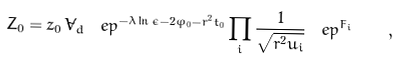Convert formula to latex. <formula><loc_0><loc_0><loc_500><loc_500>Z _ { 0 } = z _ { 0 } \, \tilde { V } _ { d } \, \ e p ^ { - \lambda \ln \epsilon - 2 \varphi _ { 0 } - r ^ { 2 } t _ { 0 } } \prod _ { i } \frac { 1 } { \sqrt { r ^ { 2 } u _ { i } } } \, \ e p ^ { F _ { i } } \quad ,</formula> 